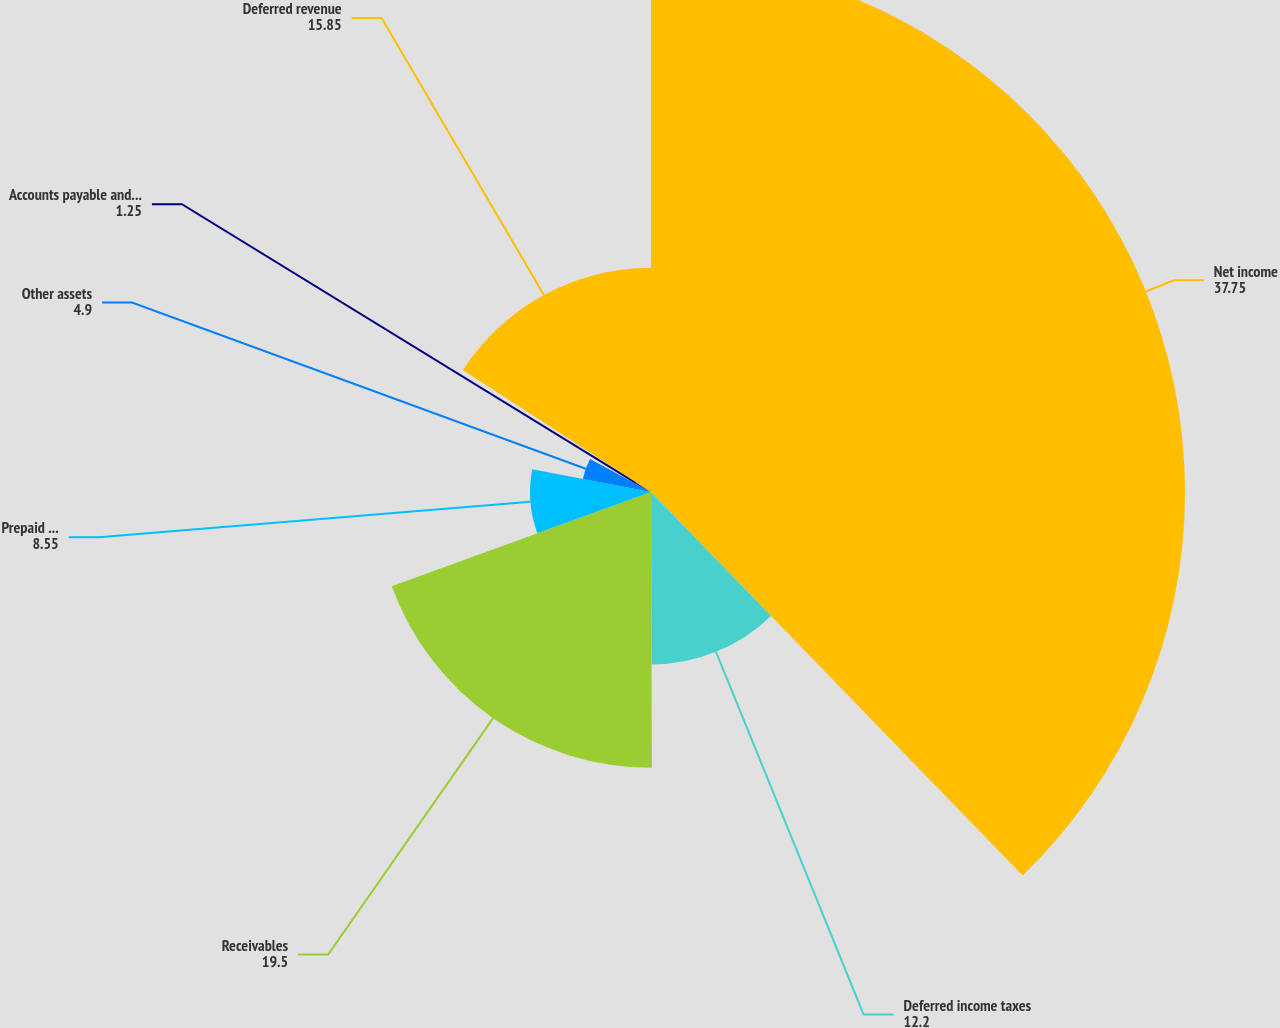Convert chart. <chart><loc_0><loc_0><loc_500><loc_500><pie_chart><fcel>Net income<fcel>Deferred income taxes<fcel>Receivables<fcel>Prepaid expenses and other<fcel>Other assets<fcel>Accounts payable and accrued<fcel>Deferred revenue<nl><fcel>37.75%<fcel>12.2%<fcel>19.5%<fcel>8.55%<fcel>4.9%<fcel>1.25%<fcel>15.85%<nl></chart> 